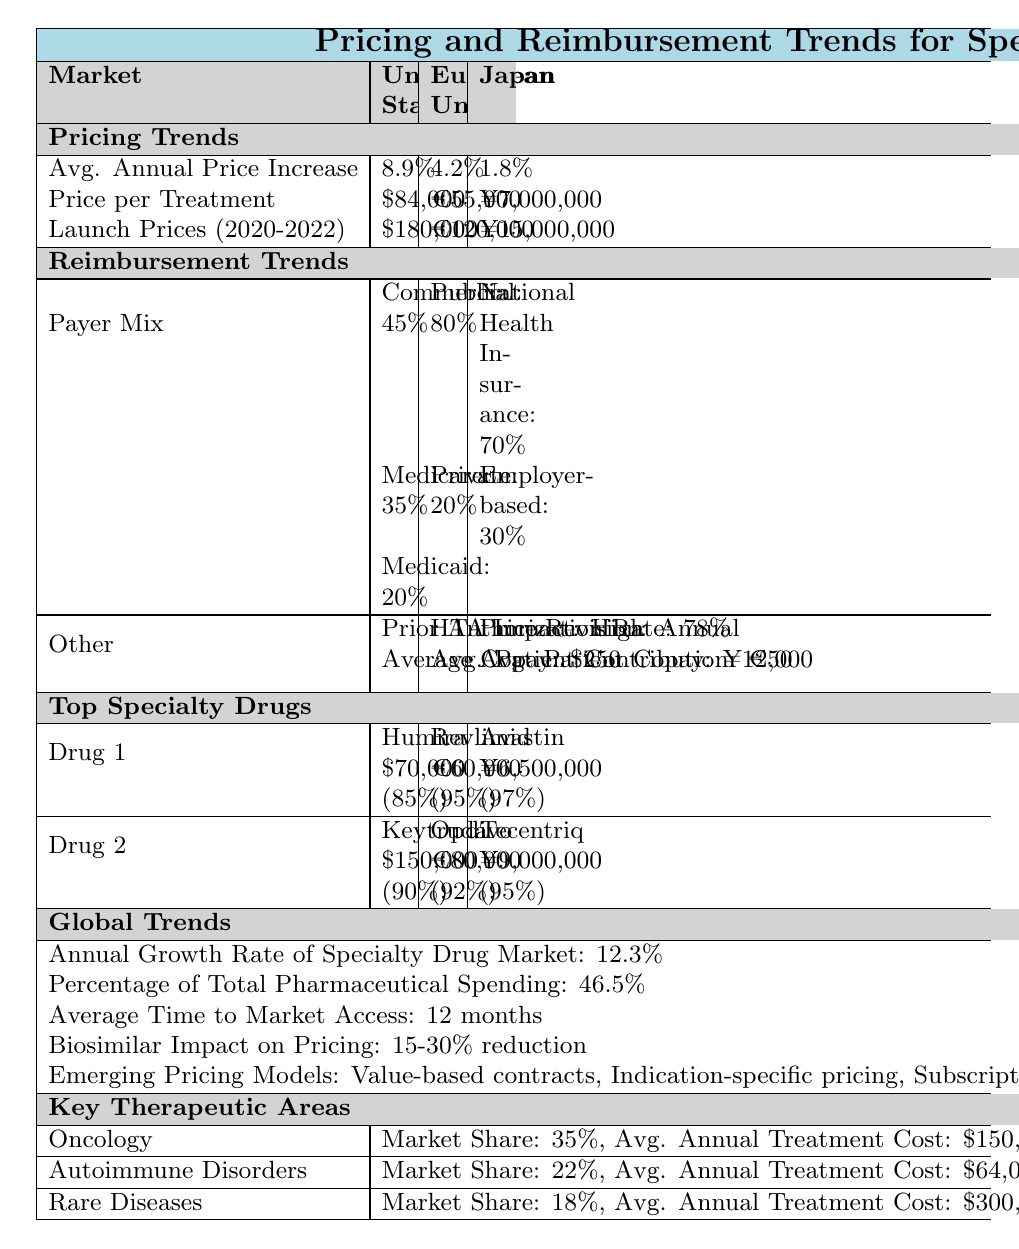What is the average annual price increase for specialty drugs in the United States? According to the table, the average annual price increase for specialty drugs in the United States is listed as 8.9%.
Answer: 8.9% What is the price per treatment for specialty drugs in the European Union? The table shows the price per treatment for specialty drugs in the European Union is €55,000.
Answer: €55,000 Does Japan have a higher average annual price increase for specialty drugs compared to the European Union? The average annual price increase in Japan is 1.8%, while in the European Union it is 4.2%. Since 1.8% is less than 4.2%, Japan does not have a higher price increase.
Answer: No What percentage of the payer mix for specialty drugs in the United States is covered by Medicaid? The table indicates that the Medicaid payer mix in the United States accounts for 20%.
Answer: 20% What is the reimbursement rate for Humira in the United States? The table lists the reimbursement rate for Humira as 85% in the United States.
Answer: 85% What is the total market share of oncology and autoimmune disorders combined? The market share for oncology is 35% and for autoimmune disorders it is 22%. Adding these together gives 35% + 22% = 57%.
Answer: 57% How much does the average patient contribute under the reimbursement trends in the European Union? The table indicates that the average patient contribution in the European Union is €50.
Answer: €50 Which market has the highest average annual treatment cost and what is that cost? Among the listed markets, rare diseases have the highest average annual treatment cost at $300,000. The table explicitly states this figure.
Answer: $300,000 What is the annual growth rate of the specialty drug market globally? The table indicates that the annual growth rate for the specialty drug market is 12.3%.
Answer: 12.3% Does the reimbursement rate for Opdivo in the European Union exceed 90%? The table shows that the reimbursement rate for Opdivo is 92%, which does exceed 90%.
Answer: Yes What is the combined reimbursement rate for the top specialty drugs listed in Japan? Avastin has a reimbursement rate of 97% and Tecentriq has a rate of 95%. Adding these gives 97% + 95% = 192%. Since there are 2 drugs, to find the average, we divide 192% by 2, resulting in 96%.
Answer: 96% 